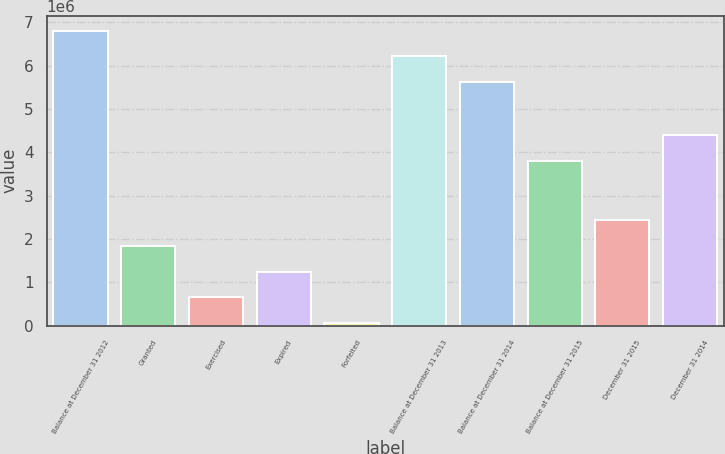<chart> <loc_0><loc_0><loc_500><loc_500><bar_chart><fcel>Balance at December 31 2012<fcel>Granted<fcel>Exercised<fcel>Expired<fcel>Forfeited<fcel>Balance at December 31 2013<fcel>Balance at December 31 2014<fcel>Balance at December 31 2015<fcel>December 31 2015<fcel>December 31 2014<nl><fcel>6.80839e+06<fcel>1.83971e+06<fcel>661824<fcel>1.25077e+06<fcel>72880<fcel>6.21945e+06<fcel>5.6305e+06<fcel>3.8041e+06<fcel>2.42866e+06<fcel>4.39304e+06<nl></chart> 